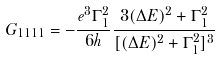Convert formula to latex. <formula><loc_0><loc_0><loc_500><loc_500>G _ { 1 1 1 1 } = - \frac { e ^ { 3 } \Gamma _ { 1 } ^ { 2 } } { 6 h } \frac { 3 ( \Delta E ) ^ { 2 } + \Gamma _ { 1 } ^ { 2 } } { [ ( \Delta E ) ^ { 2 } + \Gamma _ { 1 } ^ { 2 } ] ^ { 3 } }</formula> 